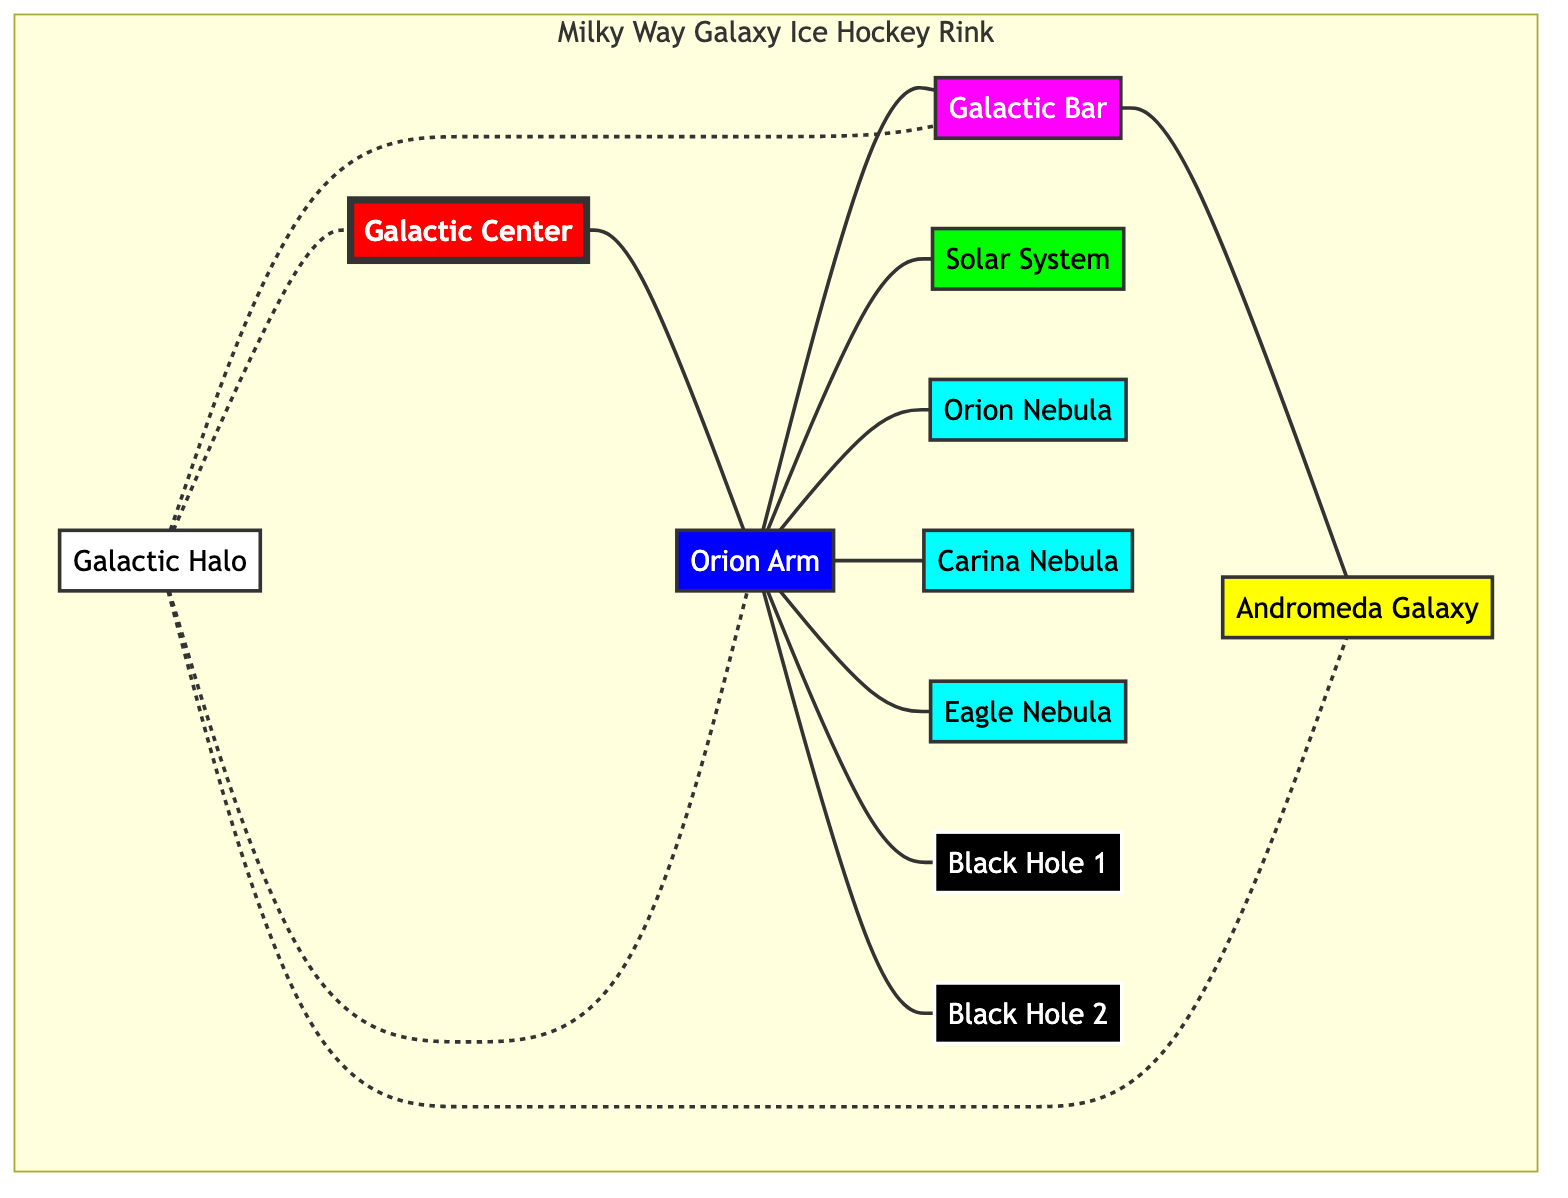What node represents the center of the Milky Way Galaxy? The node labeled "Galactic Center" is connected to the rest of the diagram, indicating it's the central point of the Milky Way.
Answer: Galactic Center How many black holes are represented in the diagram? There are two nodes labeled "Black Hole 1" and "Black Hole 2", confirming there are two black holes shown in the diagram.
Answer: 2 Which arm of the Milky Way is connected to the Solar System? The node labeled "Orion Arm" is directly linked to the "Solar System", showing the relationship of connection.
Answer: Orion Arm Which nebula is mentioned in conjunction with the Orion Arm? There are three nodes labeled "Orion Nebula", "Carina Nebula", and "Eagle Nebula" that connect to the "Orion Arm", but any of them could be acceptable.
Answer: Orion Nebula What celestial structure surrounds the entire Milky Way Galaxy? The "Galactic Halo" node is shown as an outer layer surrounding the main components of the galaxy in the diagram.
Answer: Galactic Halo Which galaxy is represented as a key player in the diagram? The node labeled "Andromeda Galaxy" connects to the "Galactic Bar", making it a significant element in this mapping of the Milky Way.
Answer: Andromeda Galaxy How many nodes represent nebulae in the Milky Way Galaxy? There are three nodes labeled "Orion Nebula", "Carina Nebula", and "Eagle Nebula" representing the nebulae in the diagram.
Answer: 3 What is the connection type between the Galactic Halo and the Galactic Center? The diagram shows a dashed line (" -.- ") representing a weaker or non-direct connection from the Halo to the Center.
Answer: Dashed line Which two main components are directly linked to the Galactic Bar? The "Orion Arm" and the "Andromeda Galaxy" are the nodes directly connected to the "Galactic Bar" in the diagram.
Answer: Orion Arm, Andromeda Galaxy 